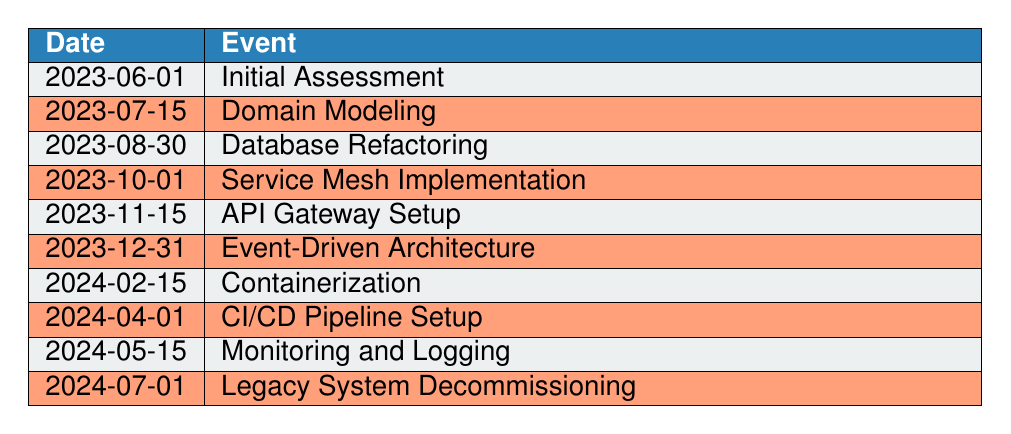What is the event that takes place on 2023-08-30? The table indicates that on 2023-08-30, the event is "Database Refactoring."
Answer: Database Refactoring What is the second event listed in the timeline? The second event in the table is the one listed under the date 2023-07-15, which is "Domain Modeling."
Answer: Domain Modeling Is there an event scheduled for 2024-02-15? Yes, the table shows that on 2024-02-15, the event is "Containerization."
Answer: Yes How many events are scheduled before 2024? The table lists 8 events occurring before the year 2024, specifically from June 2023 to December 2023.
Answer: 8 What event comes immediately after "API Gateway Setup"? According to the table, the event that follows "API Gateway Setup," which occurs on 2023-11-15, is "Event-Driven Architecture" on 2023-12-31.
Answer: Event-Driven Architecture On what date is the "Monitoring and Logging" event scheduled? The table specifies that the "Monitoring and Logging" event is scheduled for 2024-05-15.
Answer: 2024-05-15 How many months are there between "Service Mesh Implementation" and "API Gateway Setup"? "Service Mesh Implementation" is on 2023-10-01 and "API Gateway Setup" is on 2023-11-15. Calculating the months, there is 1 month and 15 days between these two events.
Answer: 1 month and 15 days What are the first and last events listed in the timeline? The first event on the timeline is "Initial Assessment" on 2023-06-01, and the last event listed is "Legacy System Decommissioning" on 2024-07-01.
Answer: Initial Assessment and Legacy System Decommissioning How many events are focused on database or data management tasks? There are 3 events that focus on database or data management tasks: "Database Refactoring," "Event-Driven Architecture," and "Monitoring and Logging."
Answer: 3 